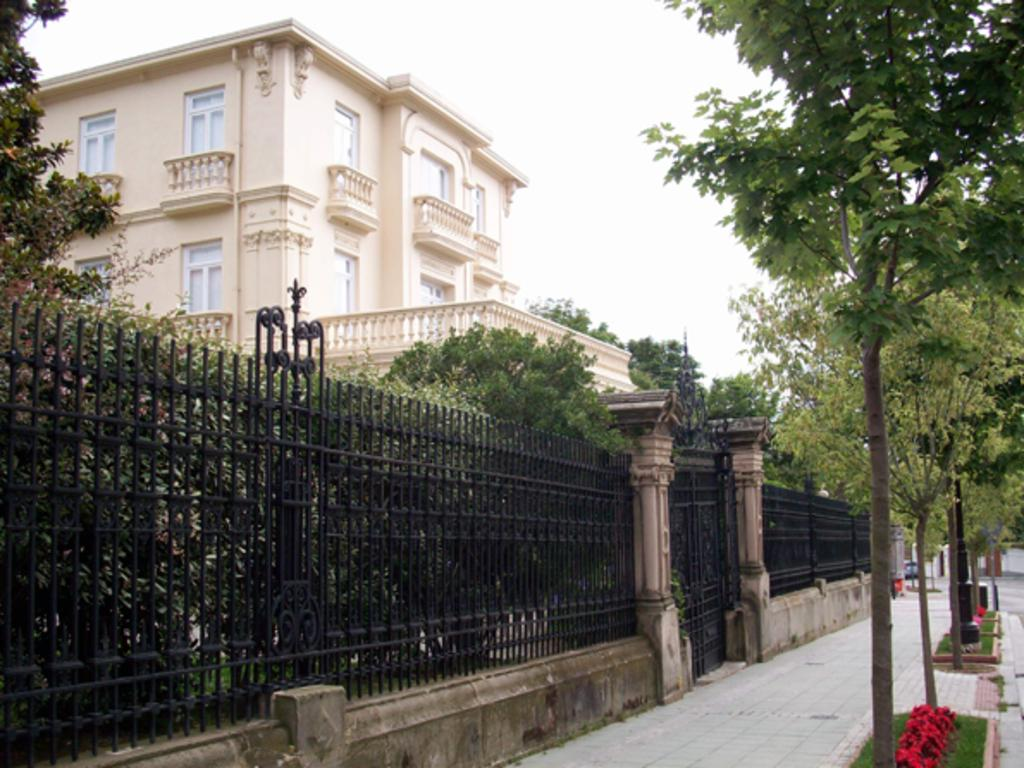What type of vegetation can be seen on the right side of the image? There are trees, plants, and grass on the right side of the image. What is the purpose of the footpath on the right side of the image? The footpath on the right side of the image is likely for walking or traversing the area. What type of structure is located on the left side of the image? There is a building on the left side of the image. What type of vegetation can be seen on the left side of the image? There are trees on the left side of the image. What feature is present on the left side of the image that might be used for safety or support? There is a railing on the left side of the image. Where is the cave located in the image? There is no cave present in the image. What type of transportation can be seen on the footpath in the image? There is no transportation, such as a train, present on the footpath in the image. 